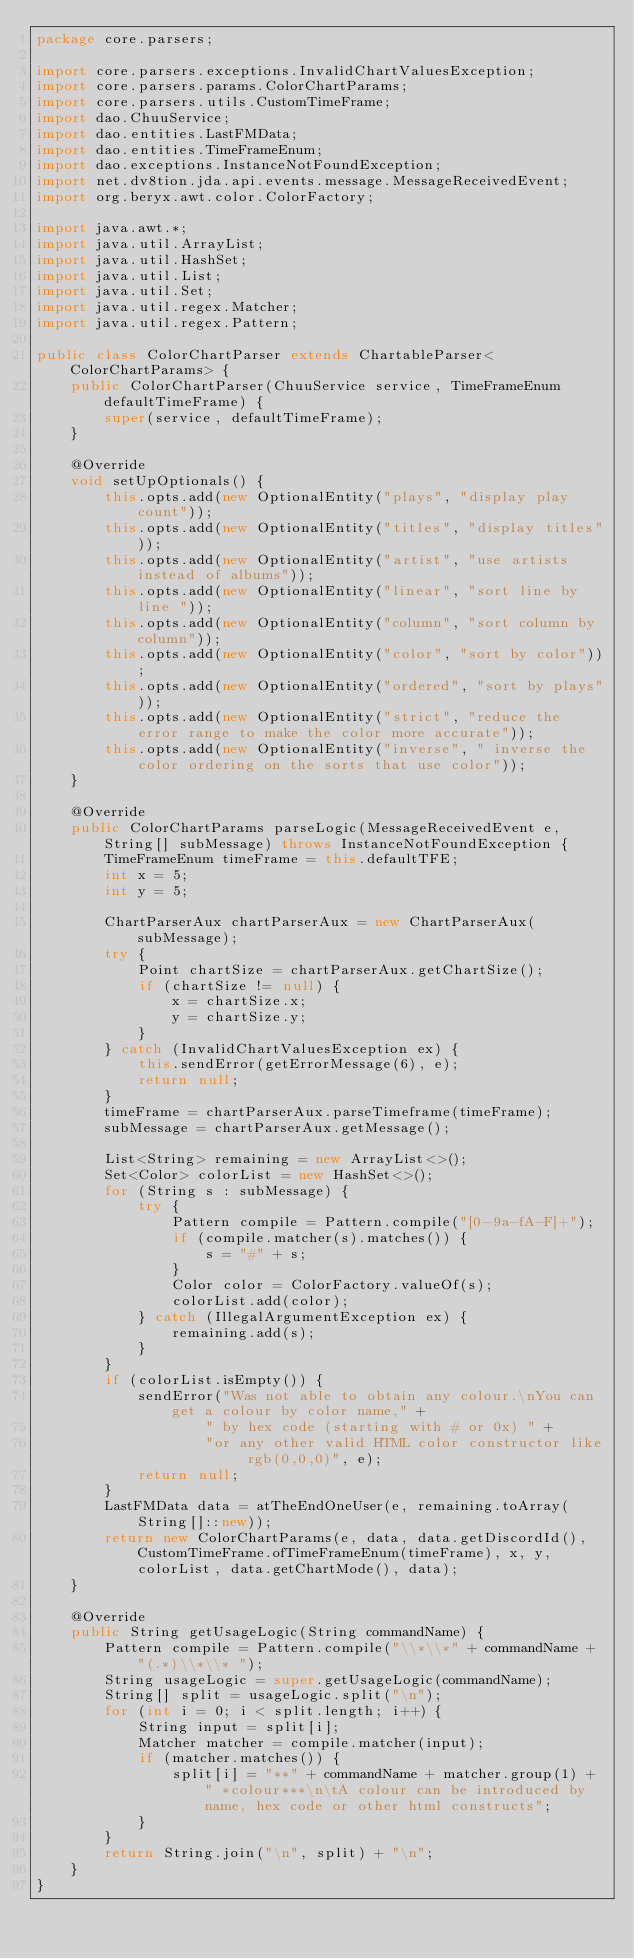Convert code to text. <code><loc_0><loc_0><loc_500><loc_500><_Java_>package core.parsers;

import core.parsers.exceptions.InvalidChartValuesException;
import core.parsers.params.ColorChartParams;
import core.parsers.utils.CustomTimeFrame;
import dao.ChuuService;
import dao.entities.LastFMData;
import dao.entities.TimeFrameEnum;
import dao.exceptions.InstanceNotFoundException;
import net.dv8tion.jda.api.events.message.MessageReceivedEvent;
import org.beryx.awt.color.ColorFactory;

import java.awt.*;
import java.util.ArrayList;
import java.util.HashSet;
import java.util.List;
import java.util.Set;
import java.util.regex.Matcher;
import java.util.regex.Pattern;

public class ColorChartParser extends ChartableParser<ColorChartParams> {
    public ColorChartParser(ChuuService service, TimeFrameEnum defaultTimeFrame) {
        super(service, defaultTimeFrame);
    }

    @Override
    void setUpOptionals() {
        this.opts.add(new OptionalEntity("plays", "display play count"));
        this.opts.add(new OptionalEntity("titles", "display titles"));
        this.opts.add(new OptionalEntity("artist", "use artists instead of albums"));
        this.opts.add(new OptionalEntity("linear", "sort line by line "));
        this.opts.add(new OptionalEntity("column", "sort column by column"));
        this.opts.add(new OptionalEntity("color", "sort by color"));
        this.opts.add(new OptionalEntity("ordered", "sort by plays"));
        this.opts.add(new OptionalEntity("strict", "reduce the error range to make the color more accurate"));
        this.opts.add(new OptionalEntity("inverse", " inverse the color ordering on the sorts that use color"));
    }

    @Override
    public ColorChartParams parseLogic(MessageReceivedEvent e, String[] subMessage) throws InstanceNotFoundException {
        TimeFrameEnum timeFrame = this.defaultTFE;
        int x = 5;
        int y = 5;

        ChartParserAux chartParserAux = new ChartParserAux(subMessage);
        try {
            Point chartSize = chartParserAux.getChartSize();
            if (chartSize != null) {
                x = chartSize.x;
                y = chartSize.y;
            }
        } catch (InvalidChartValuesException ex) {
            this.sendError(getErrorMessage(6), e);
            return null;
        }
        timeFrame = chartParserAux.parseTimeframe(timeFrame);
        subMessage = chartParserAux.getMessage();

        List<String> remaining = new ArrayList<>();
        Set<Color> colorList = new HashSet<>();
        for (String s : subMessage) {
            try {
                Pattern compile = Pattern.compile("[0-9a-fA-F]+");
                if (compile.matcher(s).matches()) {
                    s = "#" + s;
                }
                Color color = ColorFactory.valueOf(s);
                colorList.add(color);
            } catch (IllegalArgumentException ex) {
                remaining.add(s);
            }
        }
        if (colorList.isEmpty()) {
            sendError("Was not able to obtain any colour.\nYou can get a colour by color name," +
                    " by hex code (starting with # or 0x) " +
                    "or any other valid HTML color constructor like rgb(0,0,0)", e);
            return null;
        }
        LastFMData data = atTheEndOneUser(e, remaining.toArray(String[]::new));
        return new ColorChartParams(e, data, data.getDiscordId(), CustomTimeFrame.ofTimeFrameEnum(timeFrame), x, y, colorList, data.getChartMode(), data);
    }

    @Override
    public String getUsageLogic(String commandName) {
        Pattern compile = Pattern.compile("\\*\\*" + commandName + "(.*)\\*\\* ");
        String usageLogic = super.getUsageLogic(commandName);
        String[] split = usageLogic.split("\n");
        for (int i = 0; i < split.length; i++) {
            String input = split[i];
            Matcher matcher = compile.matcher(input);
            if (matcher.matches()) {
                split[i] = "**" + commandName + matcher.group(1) + " *colour***\n\tA colour can be introduced by name, hex code or other html constructs";
            }
        }
        return String.join("\n", split) + "\n";
    }
}
</code> 